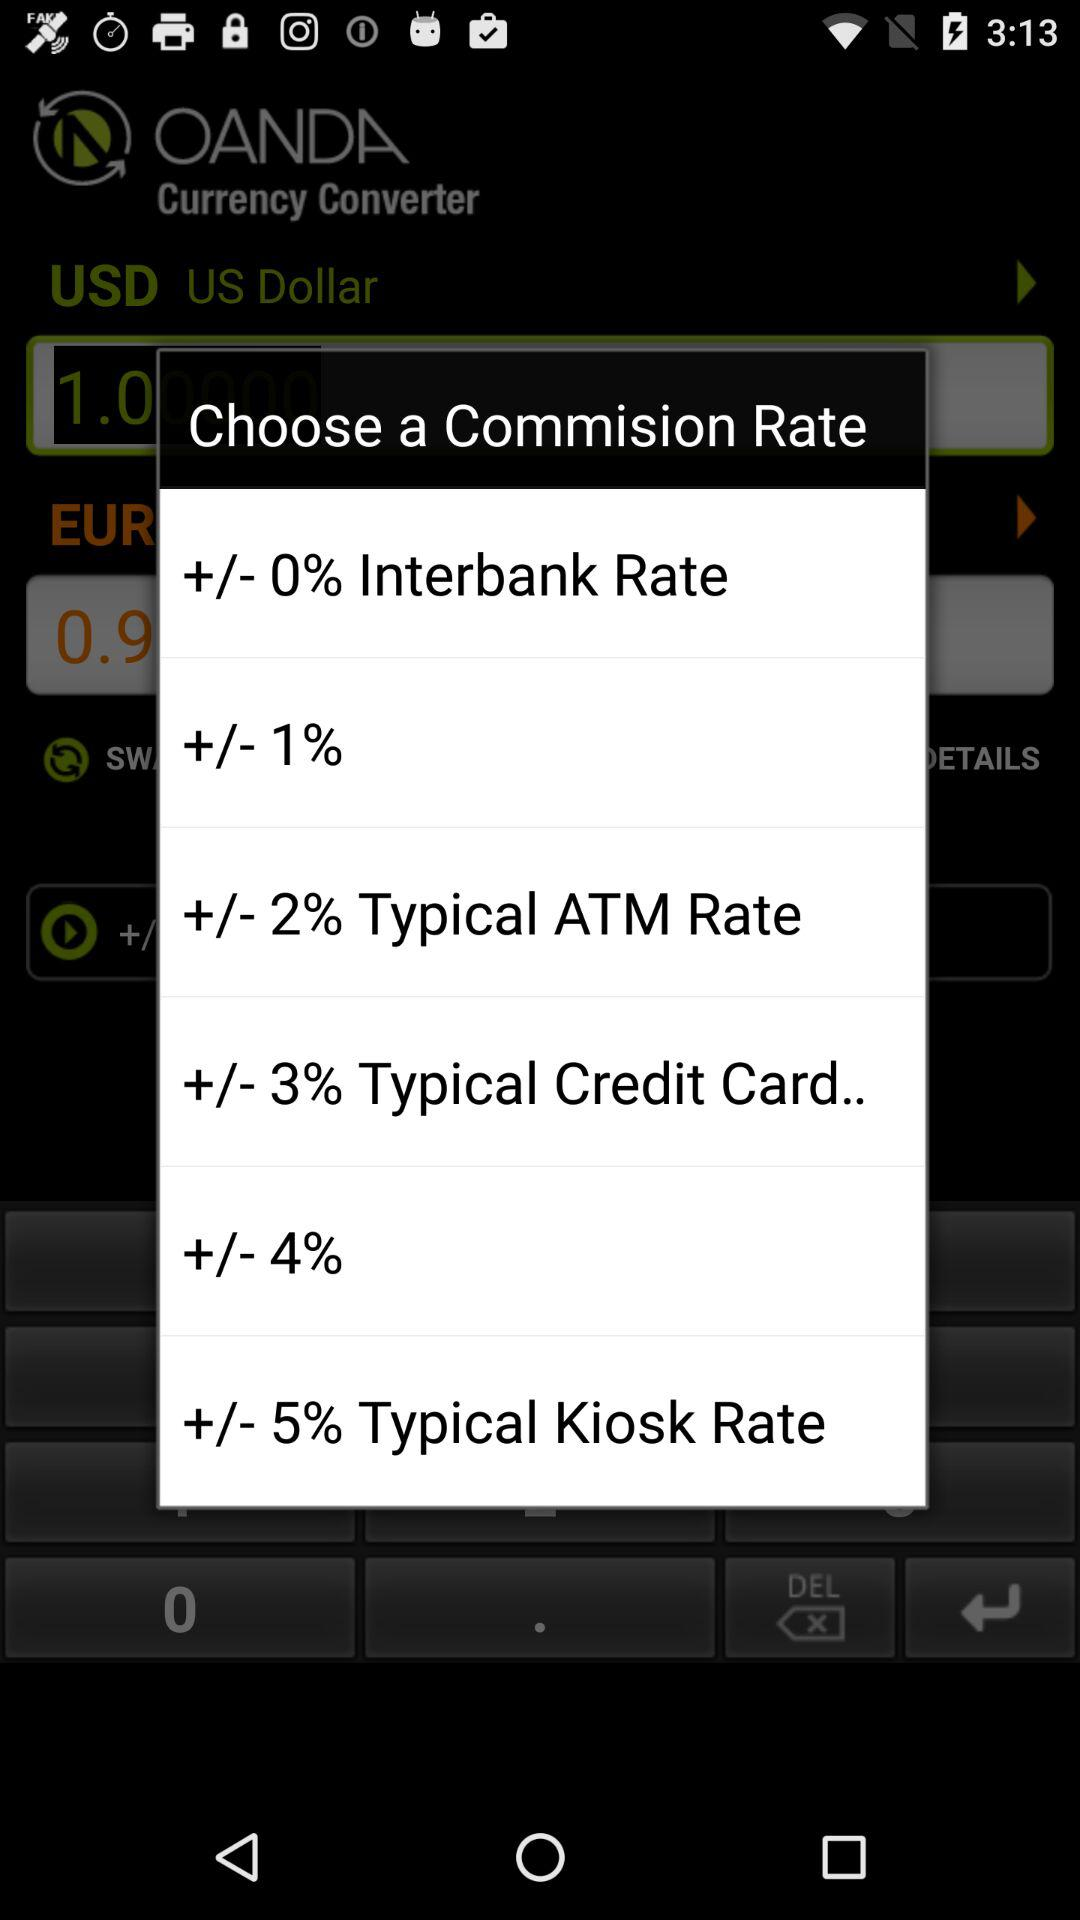What is the commission rate for the "Kiosk rate"? The commission rate is +/- 5%. 